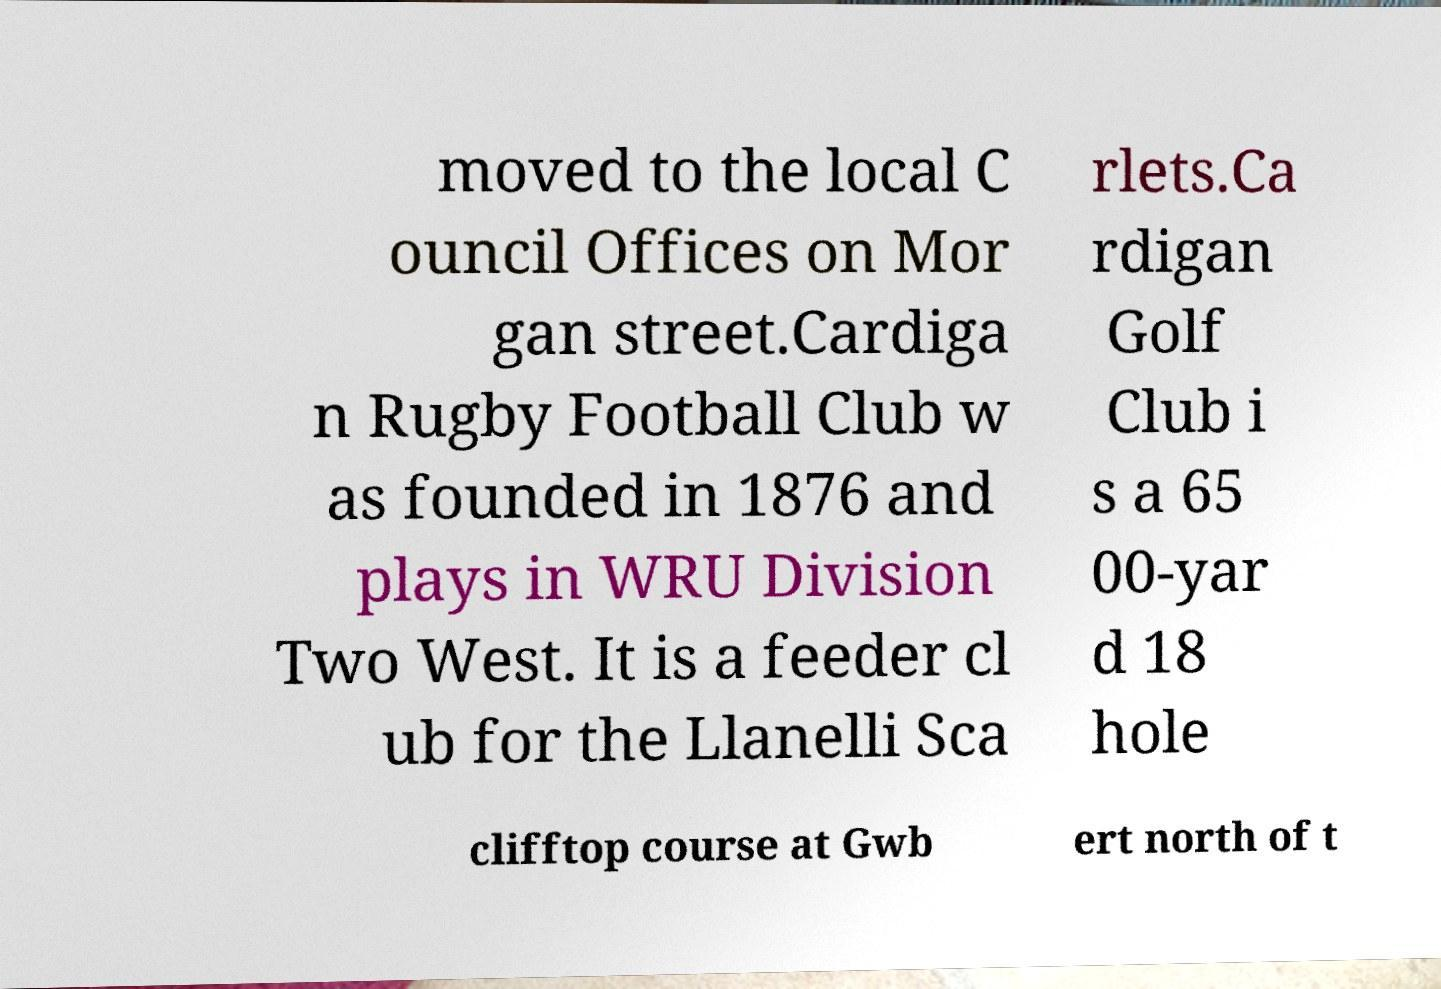Please read and relay the text visible in this image. What does it say? moved to the local C ouncil Offices on Mor gan street.Cardiga n Rugby Football Club w as founded in 1876 and plays in WRU Division Two West. It is a feeder cl ub for the Llanelli Sca rlets.Ca rdigan Golf Club i s a 65 00-yar d 18 hole clifftop course at Gwb ert north of t 